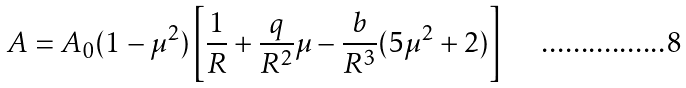<formula> <loc_0><loc_0><loc_500><loc_500>A = A _ { 0 } ( 1 - \mu ^ { 2 } ) \left [ \frac { 1 } { R } + \frac { q } { R ^ { 2 } } \mu - \frac { b } { R ^ { 3 } } ( 5 \mu ^ { 2 } + 2 ) \right ]</formula> 